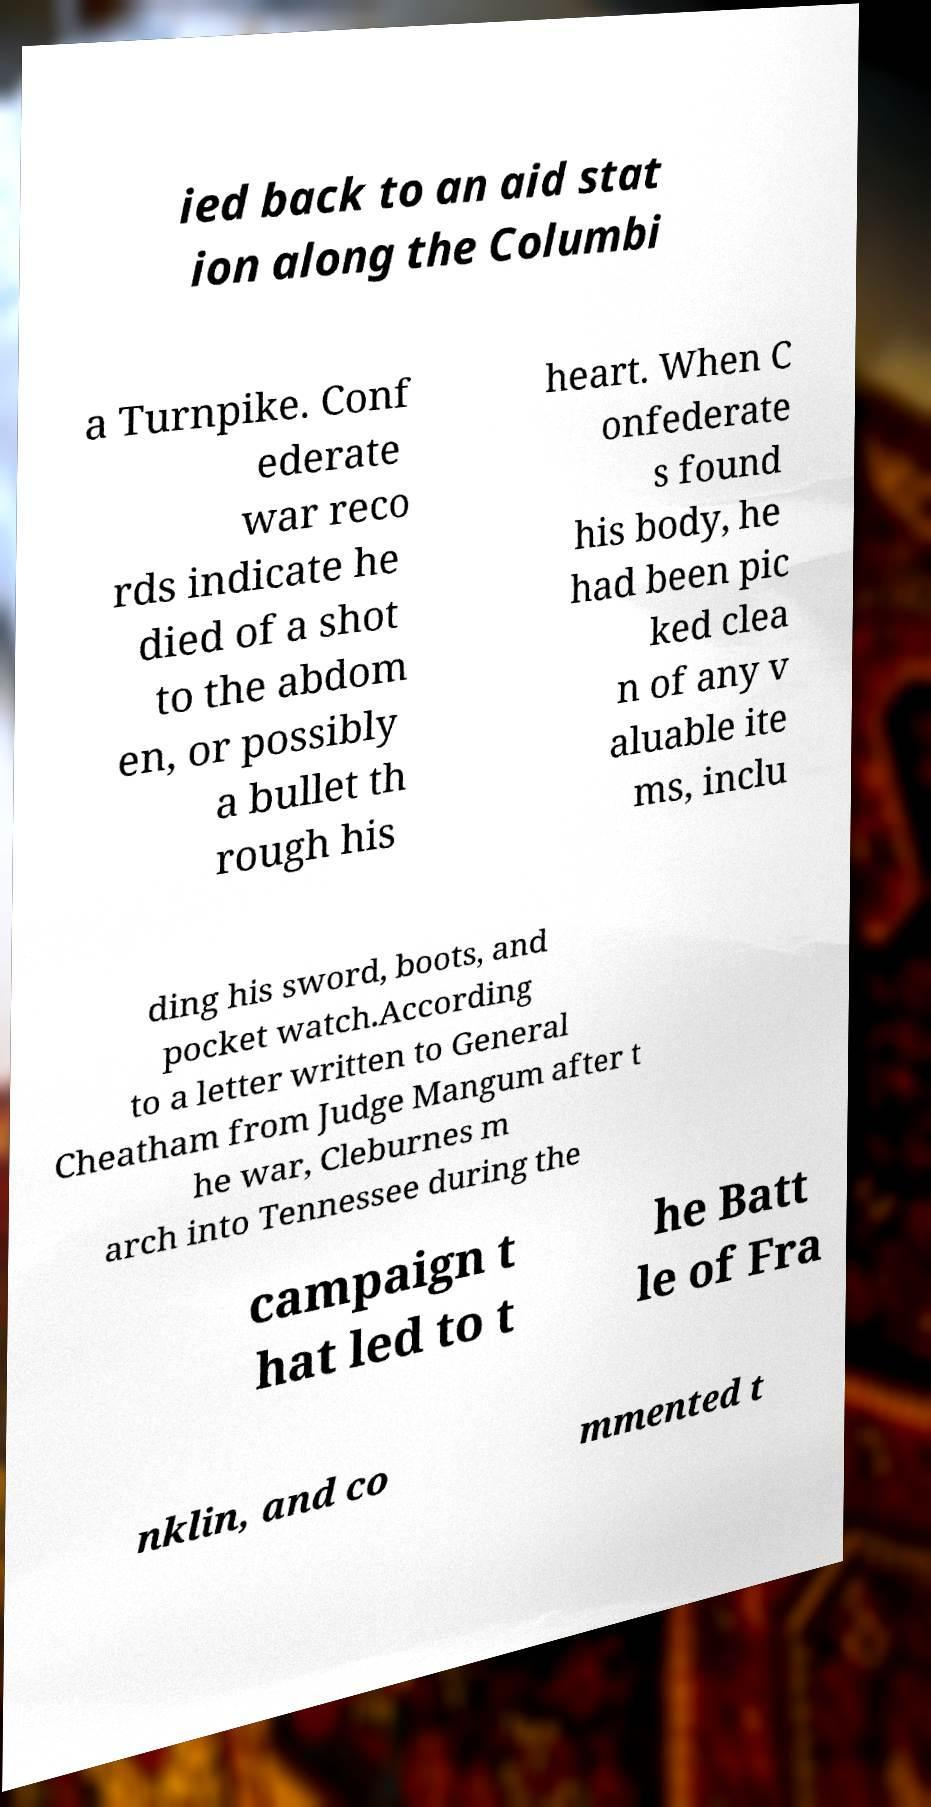What messages or text are displayed in this image? I need them in a readable, typed format. ied back to an aid stat ion along the Columbi a Turnpike. Conf ederate war reco rds indicate he died of a shot to the abdom en, or possibly a bullet th rough his heart. When C onfederate s found his body, he had been pic ked clea n of any v aluable ite ms, inclu ding his sword, boots, and pocket watch.According to a letter written to General Cheatham from Judge Mangum after t he war, Cleburnes m arch into Tennessee during the campaign t hat led to t he Batt le of Fra nklin, and co mmented t 